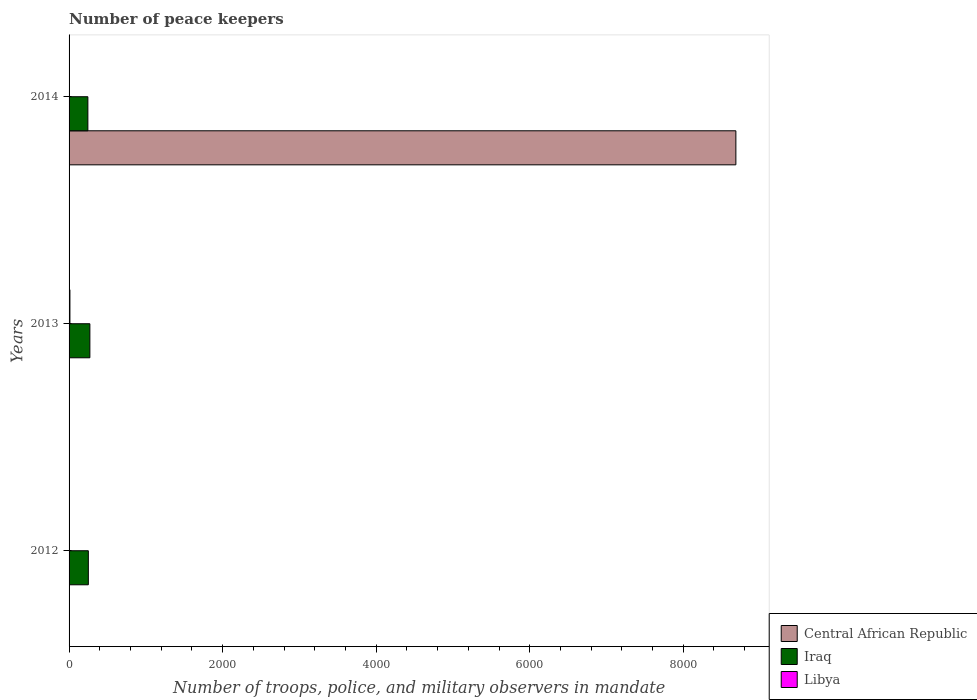Are the number of bars per tick equal to the number of legend labels?
Provide a succinct answer. Yes. How many bars are there on the 3rd tick from the top?
Offer a terse response. 3. How many bars are there on the 3rd tick from the bottom?
Your answer should be compact. 3. What is the number of peace keepers in in Central African Republic in 2014?
Provide a short and direct response. 8685. Across all years, what is the maximum number of peace keepers in in Central African Republic?
Provide a succinct answer. 8685. Across all years, what is the minimum number of peace keepers in in Libya?
Provide a succinct answer. 2. In which year was the number of peace keepers in in Iraq maximum?
Your answer should be very brief. 2013. What is the difference between the number of peace keepers in in Central African Republic in 2012 and that in 2014?
Make the answer very short. -8681. What is the difference between the number of peace keepers in in Central African Republic in 2014 and the number of peace keepers in in Iraq in 2012?
Your answer should be compact. 8434. What is the average number of peace keepers in in Iraq per year?
Offer a very short reply. 255.67. In the year 2012, what is the difference between the number of peace keepers in in Iraq and number of peace keepers in in Libya?
Offer a terse response. 249. In how many years, is the number of peace keepers in in Central African Republic greater than 1200 ?
Provide a succinct answer. 1. What is the ratio of the number of peace keepers in in Libya in 2013 to that in 2014?
Provide a short and direct response. 5.5. What is the difference between the highest and the second highest number of peace keepers in in Libya?
Offer a terse response. 9. In how many years, is the number of peace keepers in in Iraq greater than the average number of peace keepers in in Iraq taken over all years?
Ensure brevity in your answer.  1. Is the sum of the number of peace keepers in in Iraq in 2013 and 2014 greater than the maximum number of peace keepers in in Central African Republic across all years?
Your answer should be very brief. No. What does the 1st bar from the top in 2014 represents?
Provide a succinct answer. Libya. What does the 1st bar from the bottom in 2013 represents?
Your answer should be compact. Central African Republic. Is it the case that in every year, the sum of the number of peace keepers in in Central African Republic and number of peace keepers in in Iraq is greater than the number of peace keepers in in Libya?
Give a very brief answer. Yes. How many bars are there?
Keep it short and to the point. 9. How many years are there in the graph?
Offer a very short reply. 3. What is the difference between two consecutive major ticks on the X-axis?
Keep it short and to the point. 2000. Are the values on the major ticks of X-axis written in scientific E-notation?
Your answer should be very brief. No. Does the graph contain any zero values?
Provide a short and direct response. No. Does the graph contain grids?
Ensure brevity in your answer.  No. How are the legend labels stacked?
Offer a terse response. Vertical. What is the title of the graph?
Offer a terse response. Number of peace keepers. Does "Luxembourg" appear as one of the legend labels in the graph?
Your answer should be compact. No. What is the label or title of the X-axis?
Offer a terse response. Number of troops, police, and military observers in mandate. What is the Number of troops, police, and military observers in mandate of Central African Republic in 2012?
Keep it short and to the point. 4. What is the Number of troops, police, and military observers in mandate of Iraq in 2012?
Keep it short and to the point. 251. What is the Number of troops, police, and military observers in mandate in Libya in 2012?
Keep it short and to the point. 2. What is the Number of troops, police, and military observers in mandate of Central African Republic in 2013?
Your answer should be very brief. 4. What is the Number of troops, police, and military observers in mandate in Iraq in 2013?
Your response must be concise. 271. What is the Number of troops, police, and military observers in mandate of Libya in 2013?
Keep it short and to the point. 11. What is the Number of troops, police, and military observers in mandate in Central African Republic in 2014?
Make the answer very short. 8685. What is the Number of troops, police, and military observers in mandate in Iraq in 2014?
Give a very brief answer. 245. Across all years, what is the maximum Number of troops, police, and military observers in mandate in Central African Republic?
Offer a very short reply. 8685. Across all years, what is the maximum Number of troops, police, and military observers in mandate in Iraq?
Your response must be concise. 271. Across all years, what is the maximum Number of troops, police, and military observers in mandate of Libya?
Offer a very short reply. 11. Across all years, what is the minimum Number of troops, police, and military observers in mandate in Central African Republic?
Make the answer very short. 4. Across all years, what is the minimum Number of troops, police, and military observers in mandate of Iraq?
Offer a terse response. 245. What is the total Number of troops, police, and military observers in mandate of Central African Republic in the graph?
Offer a very short reply. 8693. What is the total Number of troops, police, and military observers in mandate in Iraq in the graph?
Ensure brevity in your answer.  767. What is the difference between the Number of troops, police, and military observers in mandate in Central African Republic in 2012 and that in 2013?
Your answer should be compact. 0. What is the difference between the Number of troops, police, and military observers in mandate in Iraq in 2012 and that in 2013?
Your answer should be compact. -20. What is the difference between the Number of troops, police, and military observers in mandate of Central African Republic in 2012 and that in 2014?
Provide a short and direct response. -8681. What is the difference between the Number of troops, police, and military observers in mandate of Central African Republic in 2013 and that in 2014?
Make the answer very short. -8681. What is the difference between the Number of troops, police, and military observers in mandate of Iraq in 2013 and that in 2014?
Your response must be concise. 26. What is the difference between the Number of troops, police, and military observers in mandate of Libya in 2013 and that in 2014?
Your answer should be very brief. 9. What is the difference between the Number of troops, police, and military observers in mandate of Central African Republic in 2012 and the Number of troops, police, and military observers in mandate of Iraq in 2013?
Ensure brevity in your answer.  -267. What is the difference between the Number of troops, police, and military observers in mandate in Central African Republic in 2012 and the Number of troops, police, and military observers in mandate in Libya in 2013?
Offer a very short reply. -7. What is the difference between the Number of troops, police, and military observers in mandate in Iraq in 2012 and the Number of troops, police, and military observers in mandate in Libya in 2013?
Your response must be concise. 240. What is the difference between the Number of troops, police, and military observers in mandate of Central African Republic in 2012 and the Number of troops, police, and military observers in mandate of Iraq in 2014?
Your answer should be very brief. -241. What is the difference between the Number of troops, police, and military observers in mandate of Iraq in 2012 and the Number of troops, police, and military observers in mandate of Libya in 2014?
Make the answer very short. 249. What is the difference between the Number of troops, police, and military observers in mandate in Central African Republic in 2013 and the Number of troops, police, and military observers in mandate in Iraq in 2014?
Your response must be concise. -241. What is the difference between the Number of troops, police, and military observers in mandate of Iraq in 2013 and the Number of troops, police, and military observers in mandate of Libya in 2014?
Keep it short and to the point. 269. What is the average Number of troops, police, and military observers in mandate of Central African Republic per year?
Your answer should be very brief. 2897.67. What is the average Number of troops, police, and military observers in mandate of Iraq per year?
Your response must be concise. 255.67. In the year 2012, what is the difference between the Number of troops, police, and military observers in mandate of Central African Republic and Number of troops, police, and military observers in mandate of Iraq?
Your answer should be compact. -247. In the year 2012, what is the difference between the Number of troops, police, and military observers in mandate in Iraq and Number of troops, police, and military observers in mandate in Libya?
Offer a terse response. 249. In the year 2013, what is the difference between the Number of troops, police, and military observers in mandate of Central African Republic and Number of troops, police, and military observers in mandate of Iraq?
Provide a short and direct response. -267. In the year 2013, what is the difference between the Number of troops, police, and military observers in mandate of Iraq and Number of troops, police, and military observers in mandate of Libya?
Make the answer very short. 260. In the year 2014, what is the difference between the Number of troops, police, and military observers in mandate of Central African Republic and Number of troops, police, and military observers in mandate of Iraq?
Your answer should be compact. 8440. In the year 2014, what is the difference between the Number of troops, police, and military observers in mandate in Central African Republic and Number of troops, police, and military observers in mandate in Libya?
Keep it short and to the point. 8683. In the year 2014, what is the difference between the Number of troops, police, and military observers in mandate of Iraq and Number of troops, police, and military observers in mandate of Libya?
Keep it short and to the point. 243. What is the ratio of the Number of troops, police, and military observers in mandate of Central African Republic in 2012 to that in 2013?
Make the answer very short. 1. What is the ratio of the Number of troops, police, and military observers in mandate of Iraq in 2012 to that in 2013?
Keep it short and to the point. 0.93. What is the ratio of the Number of troops, police, and military observers in mandate of Libya in 2012 to that in 2013?
Your answer should be very brief. 0.18. What is the ratio of the Number of troops, police, and military observers in mandate in Central African Republic in 2012 to that in 2014?
Give a very brief answer. 0. What is the ratio of the Number of troops, police, and military observers in mandate in Iraq in 2012 to that in 2014?
Provide a short and direct response. 1.02. What is the ratio of the Number of troops, police, and military observers in mandate of Libya in 2012 to that in 2014?
Make the answer very short. 1. What is the ratio of the Number of troops, police, and military observers in mandate in Iraq in 2013 to that in 2014?
Provide a short and direct response. 1.11. What is the difference between the highest and the second highest Number of troops, police, and military observers in mandate in Central African Republic?
Keep it short and to the point. 8681. What is the difference between the highest and the second highest Number of troops, police, and military observers in mandate of Iraq?
Your response must be concise. 20. What is the difference between the highest and the second highest Number of troops, police, and military observers in mandate of Libya?
Keep it short and to the point. 9. What is the difference between the highest and the lowest Number of troops, police, and military observers in mandate of Central African Republic?
Give a very brief answer. 8681. What is the difference between the highest and the lowest Number of troops, police, and military observers in mandate in Iraq?
Your answer should be compact. 26. 